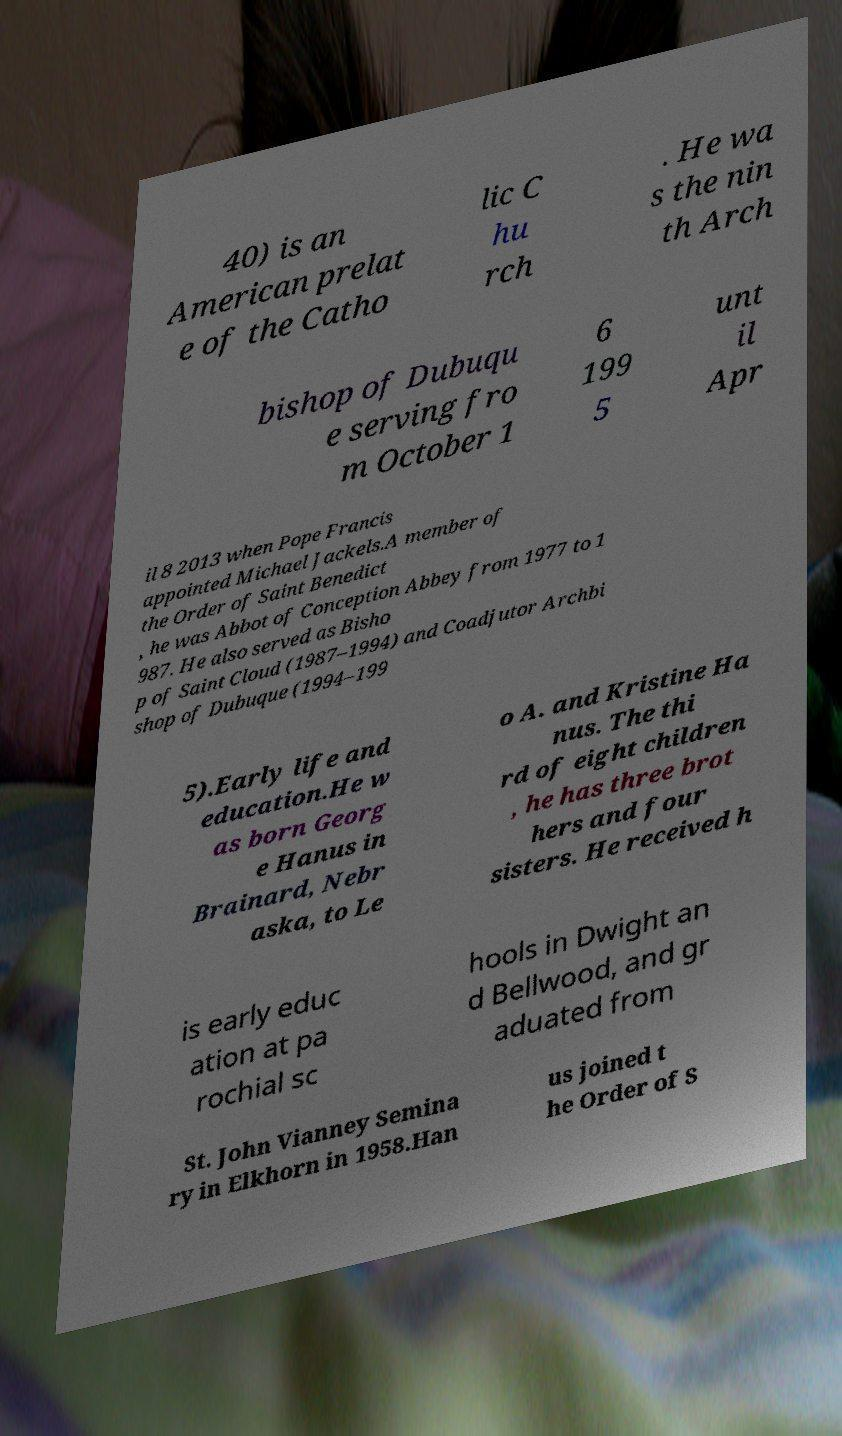What messages or text are displayed in this image? I need them in a readable, typed format. 40) is an American prelat e of the Catho lic C hu rch . He wa s the nin th Arch bishop of Dubuqu e serving fro m October 1 6 199 5 unt il Apr il 8 2013 when Pope Francis appointed Michael Jackels.A member of the Order of Saint Benedict , he was Abbot of Conception Abbey from 1977 to 1 987. He also served as Bisho p of Saint Cloud (1987–1994) and Coadjutor Archbi shop of Dubuque (1994–199 5).Early life and education.He w as born Georg e Hanus in Brainard, Nebr aska, to Le o A. and Kristine Ha nus. The thi rd of eight children , he has three brot hers and four sisters. He received h is early educ ation at pa rochial sc hools in Dwight an d Bellwood, and gr aduated from St. John Vianney Semina ry in Elkhorn in 1958.Han us joined t he Order of S 